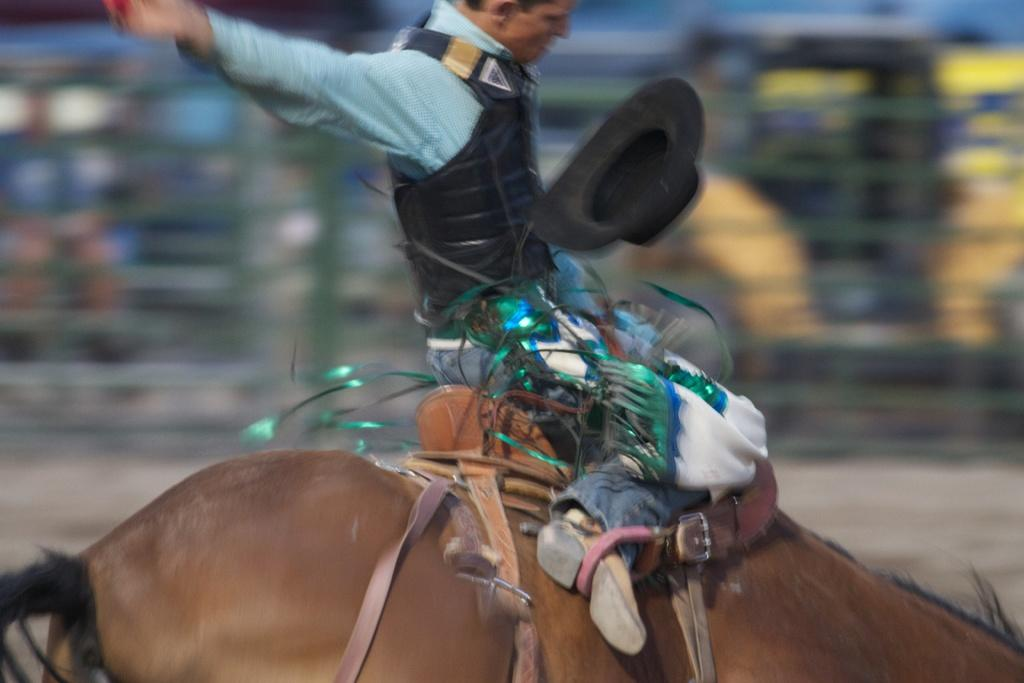What is the main subject of the image? There is a man in the image. What is the man doing in the image? The man is riding a horse. Can you describe the background of the image? The background of the image is blurry. How many rabbits can be seen sneezing in the image? There are no rabbits or sneezing in the image; it features a man riding a horse with a blurry background. 